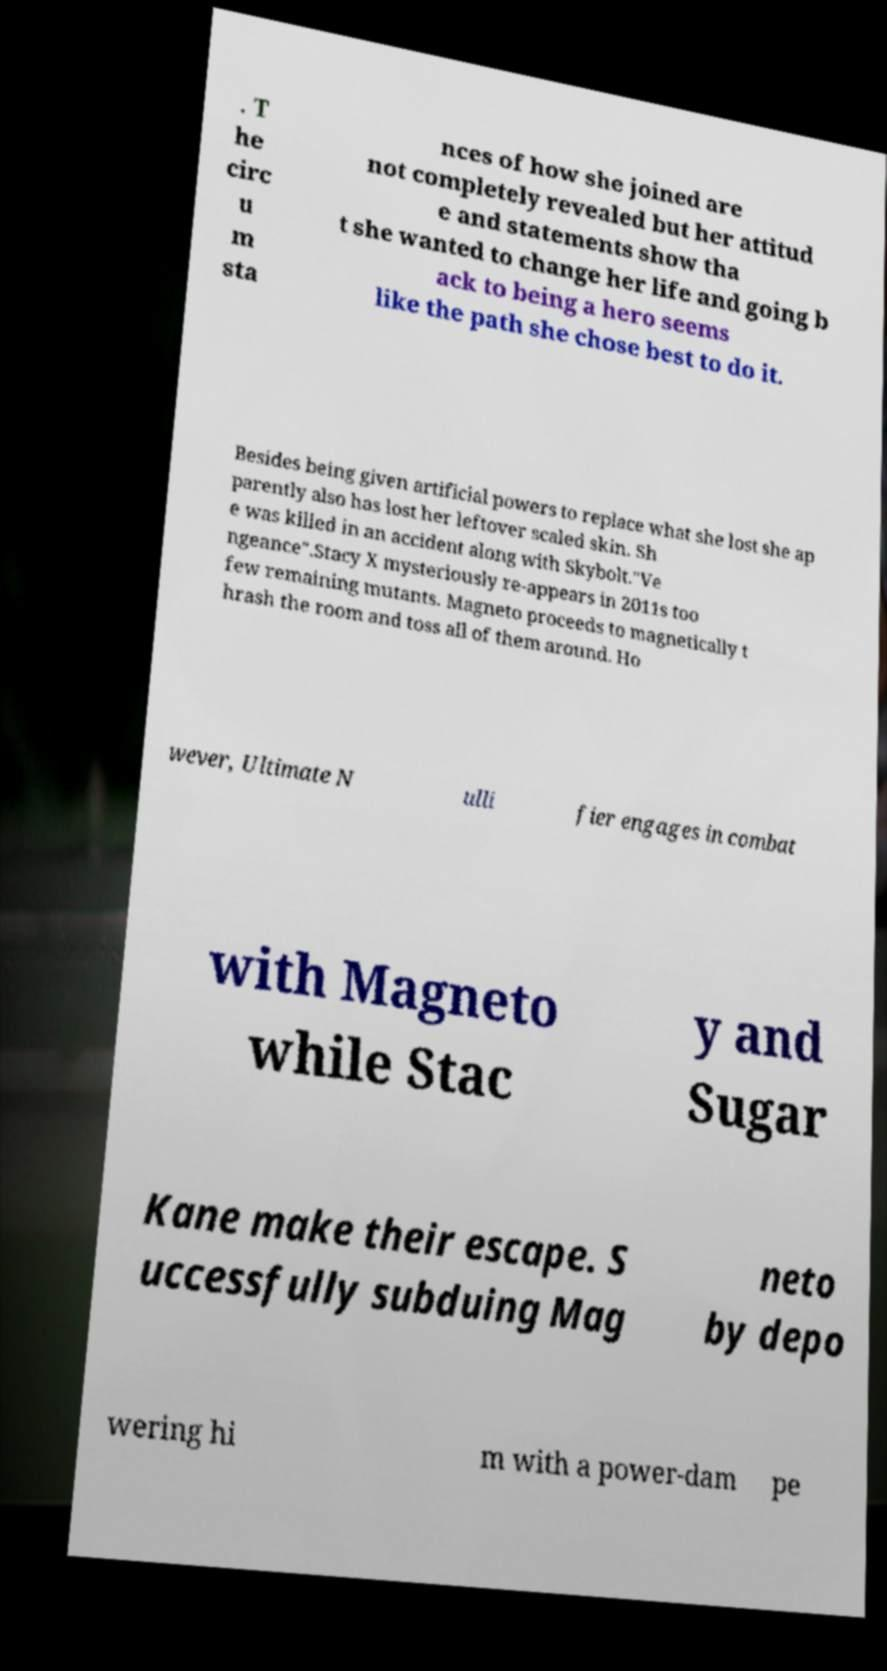Could you extract and type out the text from this image? . T he circ u m sta nces of how she joined are not completely revealed but her attitud e and statements show tha t she wanted to change her life and going b ack to being a hero seems like the path she chose best to do it. Besides being given artificial powers to replace what she lost she ap parently also has lost her leftover scaled skin. Sh e was killed in an accident along with Skybolt."Ve ngeance".Stacy X mysteriously re-appears in 2011s too few remaining mutants. Magneto proceeds to magnetically t hrash the room and toss all of them around. Ho wever, Ultimate N ulli fier engages in combat with Magneto while Stac y and Sugar Kane make their escape. S uccessfully subduing Mag neto by depo wering hi m with a power-dam pe 